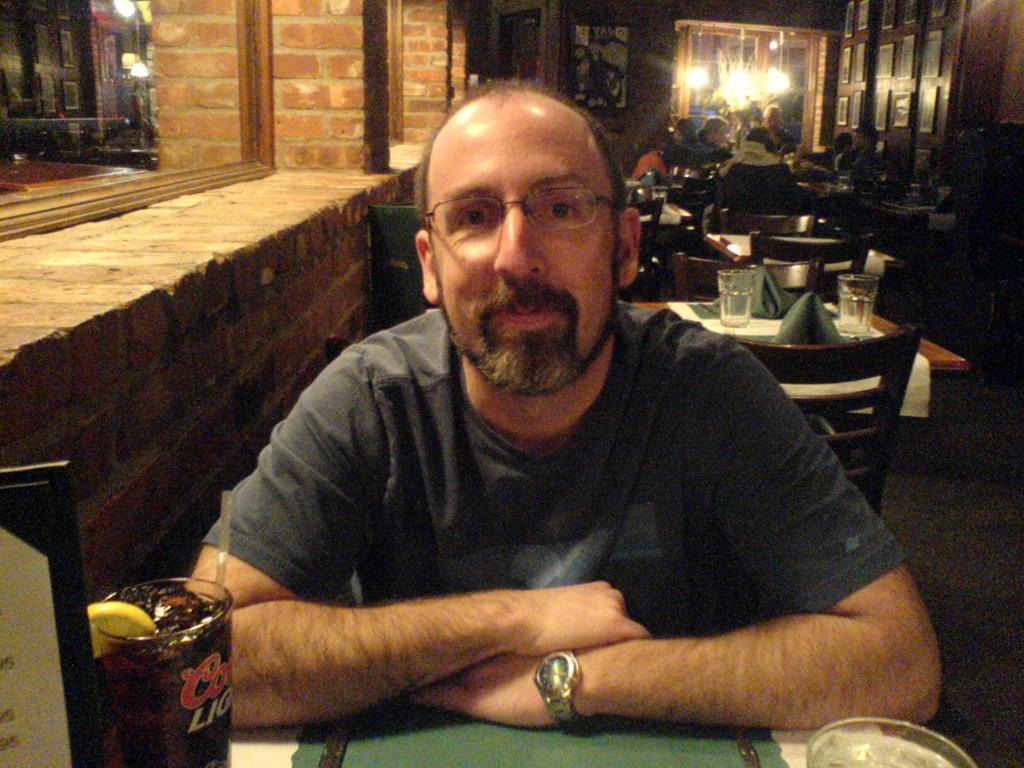In one or two sentences, can you explain what this image depicts? In this picture we can see a man wearing spectacles and sitting on the chair in front of the table on which there is a glass and behind him there are some other tables and chairs. 